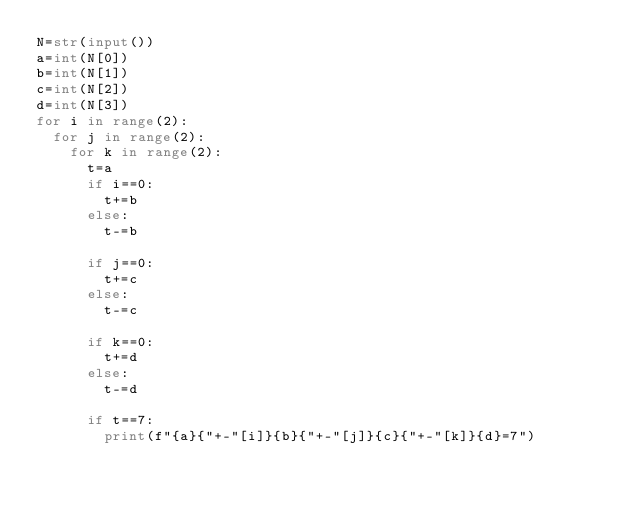<code> <loc_0><loc_0><loc_500><loc_500><_Python_>N=str(input())
a=int(N[0])
b=int(N[1])
c=int(N[2])
d=int(N[3])
for i in range(2):
  for j in range(2):
    for k in range(2):
      t=a
      if i==0:
        t+=b
      else:
        t-=b
        
      if j==0:
        t+=c
      else:
        t-=c
        
      if k==0:
        t+=d
      else:
        t-=d
        
      if t==7:
        print(f"{a}{"+-"[i]}{b}{"+-"[j]}{c}{"+-"[k]}{d}=7")
  
        
  </code> 